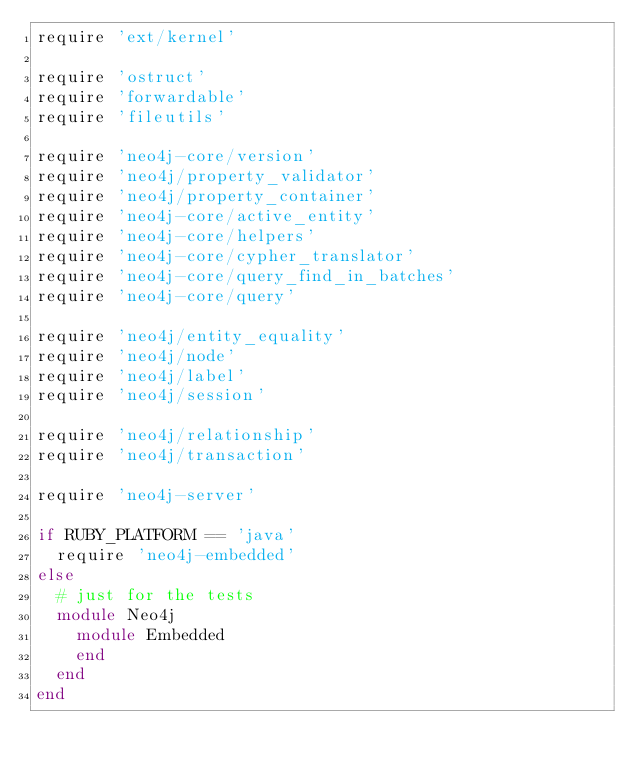Convert code to text. <code><loc_0><loc_0><loc_500><loc_500><_Ruby_>require 'ext/kernel'

require 'ostruct'
require 'forwardable'
require 'fileutils'

require 'neo4j-core/version'
require 'neo4j/property_validator'
require 'neo4j/property_container'
require 'neo4j-core/active_entity'
require 'neo4j-core/helpers'
require 'neo4j-core/cypher_translator'
require 'neo4j-core/query_find_in_batches'
require 'neo4j-core/query'

require 'neo4j/entity_equality'
require 'neo4j/node'
require 'neo4j/label'
require 'neo4j/session'

require 'neo4j/relationship'
require 'neo4j/transaction'

require 'neo4j-server'

if RUBY_PLATFORM == 'java'
  require 'neo4j-embedded'
else
  # just for the tests
  module Neo4j
    module Embedded
    end
  end
end
</code> 